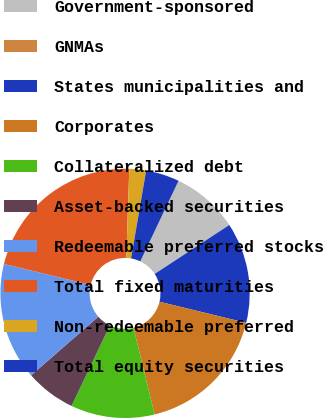Convert chart to OTSL. <chart><loc_0><loc_0><loc_500><loc_500><pie_chart><fcel>Government-sponsored<fcel>GNMAs<fcel>States municipalities and<fcel>Corporates<fcel>Collateralized debt<fcel>Asset-backed securities<fcel>Redeemable preferred stocks<fcel>Total fixed maturities<fcel>Non-redeemable preferred<fcel>Total equity securities<nl><fcel>8.7%<fcel>0.0%<fcel>13.04%<fcel>17.39%<fcel>10.87%<fcel>6.52%<fcel>15.22%<fcel>21.74%<fcel>2.17%<fcel>4.35%<nl></chart> 